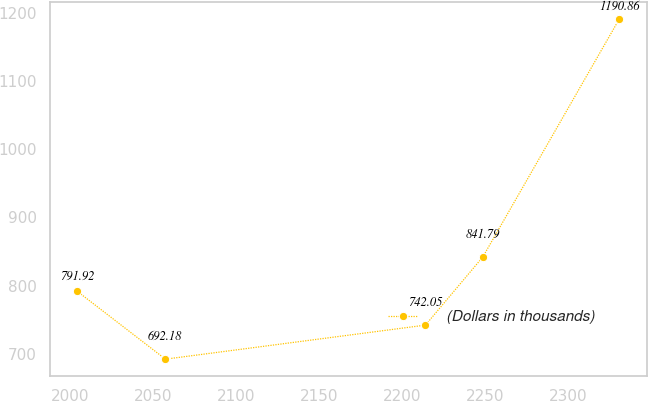Convert chart to OTSL. <chart><loc_0><loc_0><loc_500><loc_500><line_chart><ecel><fcel>(Dollars in thousands)<nl><fcel>2003.87<fcel>791.92<nl><fcel>2057.21<fcel>692.18<nl><fcel>2213.96<fcel>742.05<nl><fcel>2248.51<fcel>841.79<nl><fcel>2330.9<fcel>1190.86<nl></chart> 